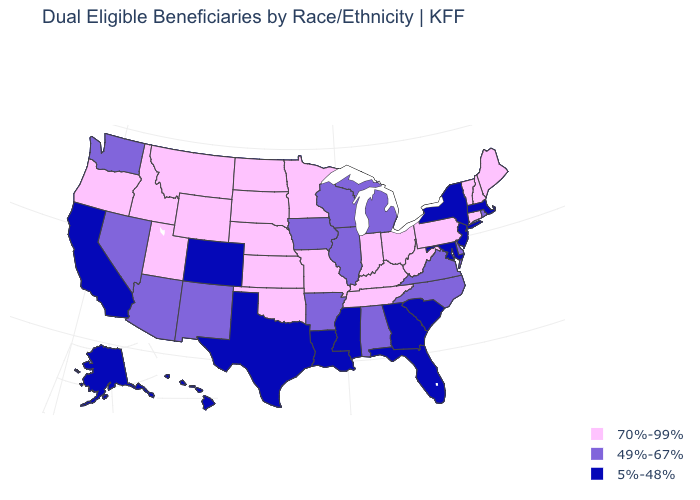Among the states that border Virginia , which have the highest value?
Keep it brief. Kentucky, Tennessee, West Virginia. What is the value of Massachusetts?
Answer briefly. 5%-48%. Name the states that have a value in the range 70%-99%?
Be succinct. Connecticut, Idaho, Indiana, Kansas, Kentucky, Maine, Minnesota, Missouri, Montana, Nebraska, New Hampshire, North Dakota, Ohio, Oklahoma, Oregon, Pennsylvania, South Dakota, Tennessee, Utah, Vermont, West Virginia, Wyoming. Does the first symbol in the legend represent the smallest category?
Concise answer only. No. Which states have the lowest value in the USA?
Short answer required. Alaska, California, Colorado, Florida, Georgia, Hawaii, Louisiana, Maryland, Massachusetts, Mississippi, New Jersey, New York, South Carolina, Texas. What is the lowest value in the Northeast?
Give a very brief answer. 5%-48%. Does Delaware have a lower value than Wisconsin?
Be succinct. No. Which states have the highest value in the USA?
Quick response, please. Connecticut, Idaho, Indiana, Kansas, Kentucky, Maine, Minnesota, Missouri, Montana, Nebraska, New Hampshire, North Dakota, Ohio, Oklahoma, Oregon, Pennsylvania, South Dakota, Tennessee, Utah, Vermont, West Virginia, Wyoming. Among the states that border Colorado , which have the lowest value?
Keep it brief. Arizona, New Mexico. Does Montana have the lowest value in the USA?
Be succinct. No. Does Oregon have a higher value than Florida?
Give a very brief answer. Yes. What is the value of Montana?
Give a very brief answer. 70%-99%. Name the states that have a value in the range 70%-99%?
Answer briefly. Connecticut, Idaho, Indiana, Kansas, Kentucky, Maine, Minnesota, Missouri, Montana, Nebraska, New Hampshire, North Dakota, Ohio, Oklahoma, Oregon, Pennsylvania, South Dakota, Tennessee, Utah, Vermont, West Virginia, Wyoming. Which states hav the highest value in the Northeast?
Keep it brief. Connecticut, Maine, New Hampshire, Pennsylvania, Vermont. 